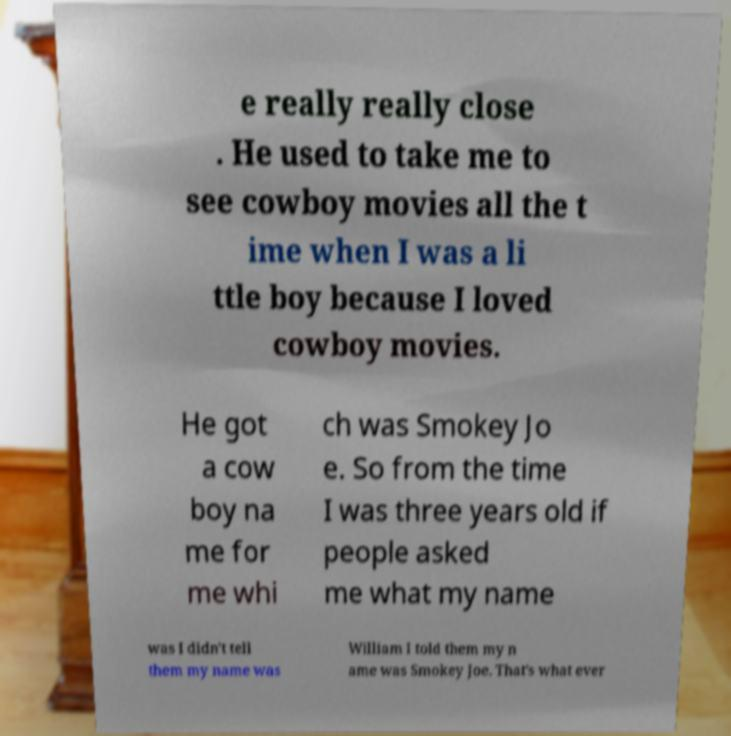What messages or text are displayed in this image? I need them in a readable, typed format. e really really close . He used to take me to see cowboy movies all the t ime when I was a li ttle boy because I loved cowboy movies. He got a cow boy na me for me whi ch was Smokey Jo e. So from the time I was three years old if people asked me what my name was I didn't tell them my name was William I told them my n ame was Smokey Joe. That's what ever 